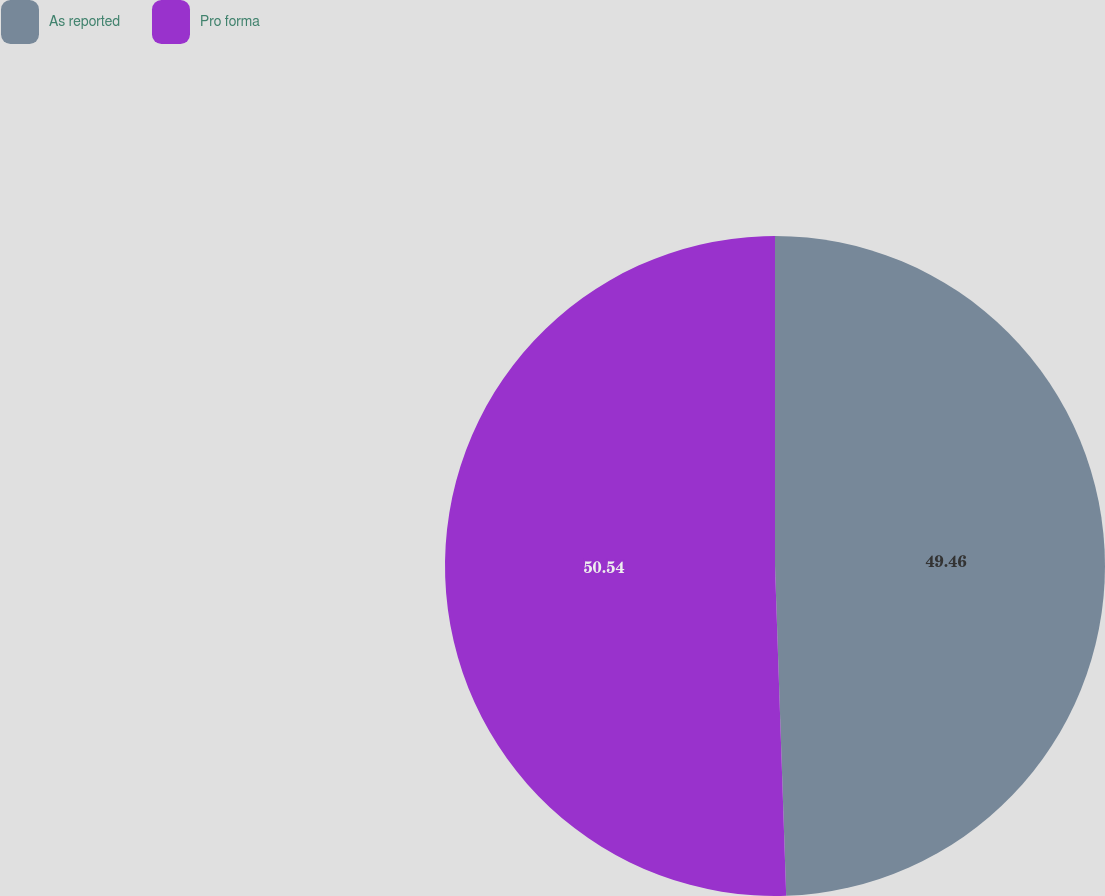Convert chart. <chart><loc_0><loc_0><loc_500><loc_500><pie_chart><fcel>As reported<fcel>Pro forma<nl><fcel>49.46%<fcel>50.54%<nl></chart> 